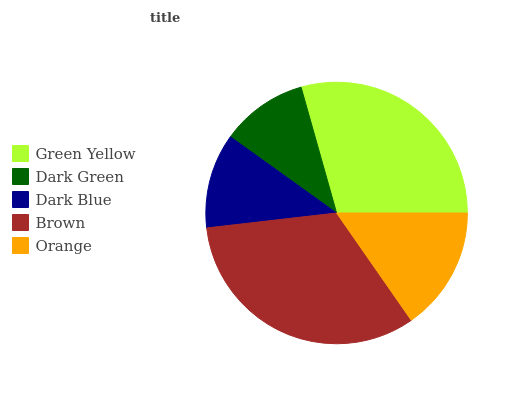Is Dark Green the minimum?
Answer yes or no. Yes. Is Brown the maximum?
Answer yes or no. Yes. Is Dark Blue the minimum?
Answer yes or no. No. Is Dark Blue the maximum?
Answer yes or no. No. Is Dark Blue greater than Dark Green?
Answer yes or no. Yes. Is Dark Green less than Dark Blue?
Answer yes or no. Yes. Is Dark Green greater than Dark Blue?
Answer yes or no. No. Is Dark Blue less than Dark Green?
Answer yes or no. No. Is Orange the high median?
Answer yes or no. Yes. Is Orange the low median?
Answer yes or no. Yes. Is Green Yellow the high median?
Answer yes or no. No. Is Dark Blue the low median?
Answer yes or no. No. 